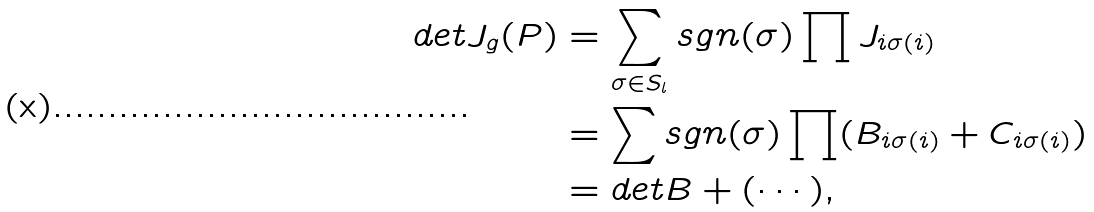<formula> <loc_0><loc_0><loc_500><loc_500>d e t J _ { g } ( P ) & = \sum _ { \sigma \in S _ { l } } s g n ( \sigma ) \prod J _ { i \sigma ( i ) } \\ & = \sum s g n ( \sigma ) \prod ( B _ { i \sigma ( i ) } + C _ { i \sigma ( i ) } ) \\ & = d e t B + ( \cdots ) ,</formula> 